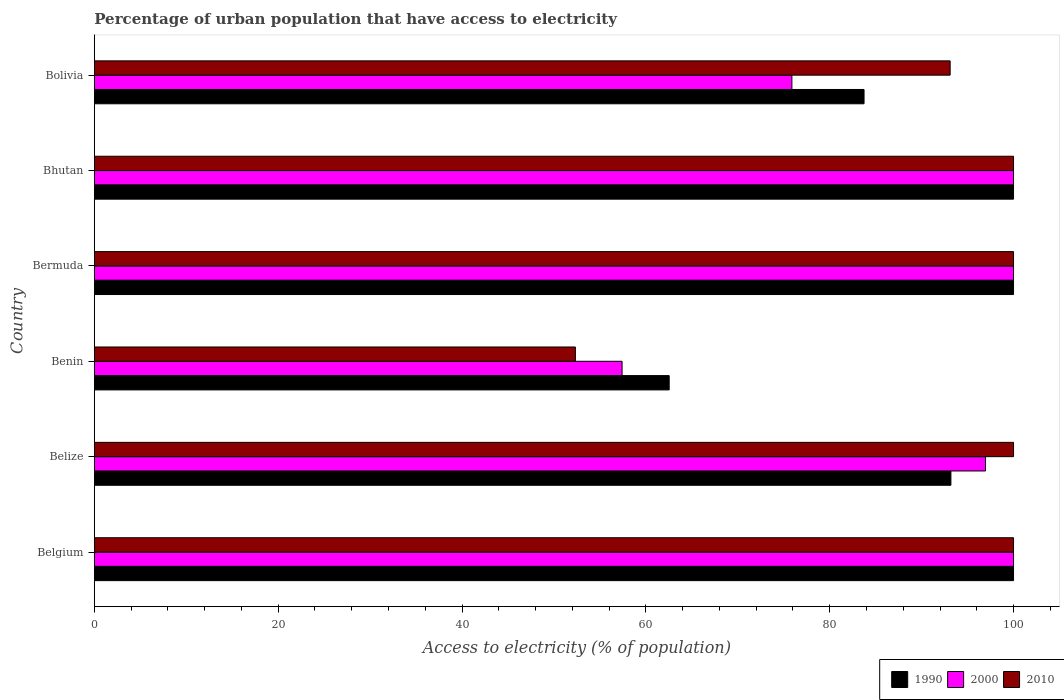How many different coloured bars are there?
Offer a very short reply. 3. How many groups of bars are there?
Your answer should be very brief. 6. Are the number of bars per tick equal to the number of legend labels?
Keep it short and to the point. Yes. Are the number of bars on each tick of the Y-axis equal?
Offer a terse response. Yes. How many bars are there on the 2nd tick from the top?
Provide a succinct answer. 3. What is the label of the 3rd group of bars from the top?
Make the answer very short. Bermuda. What is the percentage of urban population that have access to electricity in 1990 in Belgium?
Offer a terse response. 100. Across all countries, what is the minimum percentage of urban population that have access to electricity in 2000?
Offer a very short reply. 57.41. In which country was the percentage of urban population that have access to electricity in 1990 maximum?
Make the answer very short. Belgium. In which country was the percentage of urban population that have access to electricity in 2000 minimum?
Make the answer very short. Benin. What is the total percentage of urban population that have access to electricity in 2000 in the graph?
Make the answer very short. 530.25. What is the difference between the percentage of urban population that have access to electricity in 2010 in Bermuda and that in Bolivia?
Your response must be concise. 6.9. What is the difference between the percentage of urban population that have access to electricity in 2000 in Bolivia and the percentage of urban population that have access to electricity in 1990 in Belgium?
Your response must be concise. -24.11. What is the average percentage of urban population that have access to electricity in 1990 per country?
Provide a succinct answer. 89.91. What is the difference between the percentage of urban population that have access to electricity in 1990 and percentage of urban population that have access to electricity in 2010 in Benin?
Provide a short and direct response. 10.2. In how many countries, is the percentage of urban population that have access to electricity in 2000 greater than 68 %?
Your answer should be compact. 5. What is the ratio of the percentage of urban population that have access to electricity in 2010 in Benin to that in Bolivia?
Give a very brief answer. 0.56. Is the percentage of urban population that have access to electricity in 1990 in Benin less than that in Bolivia?
Ensure brevity in your answer.  Yes. What is the difference between the highest and the second highest percentage of urban population that have access to electricity in 1990?
Provide a succinct answer. 0. What is the difference between the highest and the lowest percentage of urban population that have access to electricity in 2000?
Offer a very short reply. 42.59. What does the 3rd bar from the top in Bolivia represents?
Ensure brevity in your answer.  1990. Is it the case that in every country, the sum of the percentage of urban population that have access to electricity in 2000 and percentage of urban population that have access to electricity in 1990 is greater than the percentage of urban population that have access to electricity in 2010?
Offer a very short reply. Yes. How many bars are there?
Make the answer very short. 18. How many countries are there in the graph?
Ensure brevity in your answer.  6. What is the difference between two consecutive major ticks on the X-axis?
Offer a terse response. 20. Where does the legend appear in the graph?
Ensure brevity in your answer.  Bottom right. How many legend labels are there?
Give a very brief answer. 3. How are the legend labels stacked?
Ensure brevity in your answer.  Horizontal. What is the title of the graph?
Your answer should be compact. Percentage of urban population that have access to electricity. Does "1982" appear as one of the legend labels in the graph?
Ensure brevity in your answer.  No. What is the label or title of the X-axis?
Give a very brief answer. Access to electricity (% of population). What is the label or title of the Y-axis?
Provide a succinct answer. Country. What is the Access to electricity (% of population) in 2000 in Belgium?
Ensure brevity in your answer.  100. What is the Access to electricity (% of population) in 2010 in Belgium?
Ensure brevity in your answer.  100. What is the Access to electricity (% of population) of 1990 in Belize?
Keep it short and to the point. 93.19. What is the Access to electricity (% of population) of 2000 in Belize?
Give a very brief answer. 96.95. What is the Access to electricity (% of population) in 1990 in Benin?
Offer a very short reply. 62.54. What is the Access to electricity (% of population) in 2000 in Benin?
Offer a terse response. 57.41. What is the Access to electricity (% of population) of 2010 in Benin?
Offer a very short reply. 52.33. What is the Access to electricity (% of population) of 2000 in Bermuda?
Your response must be concise. 100. What is the Access to electricity (% of population) of 2000 in Bhutan?
Provide a succinct answer. 100. What is the Access to electricity (% of population) in 2010 in Bhutan?
Your answer should be very brief. 100. What is the Access to electricity (% of population) in 1990 in Bolivia?
Ensure brevity in your answer.  83.74. What is the Access to electricity (% of population) in 2000 in Bolivia?
Give a very brief answer. 75.89. What is the Access to electricity (% of population) of 2010 in Bolivia?
Provide a short and direct response. 93.1. Across all countries, what is the maximum Access to electricity (% of population) in 1990?
Your answer should be compact. 100. Across all countries, what is the minimum Access to electricity (% of population) of 1990?
Make the answer very short. 62.54. Across all countries, what is the minimum Access to electricity (% of population) of 2000?
Offer a very short reply. 57.41. Across all countries, what is the minimum Access to electricity (% of population) in 2010?
Your response must be concise. 52.33. What is the total Access to electricity (% of population) of 1990 in the graph?
Provide a short and direct response. 539.46. What is the total Access to electricity (% of population) of 2000 in the graph?
Offer a very short reply. 530.25. What is the total Access to electricity (% of population) of 2010 in the graph?
Your answer should be very brief. 545.44. What is the difference between the Access to electricity (% of population) in 1990 in Belgium and that in Belize?
Make the answer very short. 6.81. What is the difference between the Access to electricity (% of population) in 2000 in Belgium and that in Belize?
Your response must be concise. 3.05. What is the difference between the Access to electricity (% of population) in 1990 in Belgium and that in Benin?
Provide a succinct answer. 37.46. What is the difference between the Access to electricity (% of population) in 2000 in Belgium and that in Benin?
Give a very brief answer. 42.59. What is the difference between the Access to electricity (% of population) of 2010 in Belgium and that in Benin?
Provide a succinct answer. 47.67. What is the difference between the Access to electricity (% of population) in 1990 in Belgium and that in Bermuda?
Ensure brevity in your answer.  0. What is the difference between the Access to electricity (% of population) in 2010 in Belgium and that in Bermuda?
Ensure brevity in your answer.  0. What is the difference between the Access to electricity (% of population) of 2000 in Belgium and that in Bhutan?
Offer a very short reply. 0. What is the difference between the Access to electricity (% of population) of 2010 in Belgium and that in Bhutan?
Give a very brief answer. 0. What is the difference between the Access to electricity (% of population) in 1990 in Belgium and that in Bolivia?
Keep it short and to the point. 16.26. What is the difference between the Access to electricity (% of population) in 2000 in Belgium and that in Bolivia?
Ensure brevity in your answer.  24.11. What is the difference between the Access to electricity (% of population) of 2010 in Belgium and that in Bolivia?
Give a very brief answer. 6.9. What is the difference between the Access to electricity (% of population) of 1990 in Belize and that in Benin?
Give a very brief answer. 30.65. What is the difference between the Access to electricity (% of population) of 2000 in Belize and that in Benin?
Provide a succinct answer. 39.53. What is the difference between the Access to electricity (% of population) in 2010 in Belize and that in Benin?
Your answer should be very brief. 47.67. What is the difference between the Access to electricity (% of population) of 1990 in Belize and that in Bermuda?
Your answer should be very brief. -6.81. What is the difference between the Access to electricity (% of population) in 2000 in Belize and that in Bermuda?
Your answer should be compact. -3.05. What is the difference between the Access to electricity (% of population) in 2010 in Belize and that in Bermuda?
Provide a succinct answer. 0. What is the difference between the Access to electricity (% of population) in 1990 in Belize and that in Bhutan?
Give a very brief answer. -6.81. What is the difference between the Access to electricity (% of population) in 2000 in Belize and that in Bhutan?
Your answer should be compact. -3.05. What is the difference between the Access to electricity (% of population) of 1990 in Belize and that in Bolivia?
Your response must be concise. 9.45. What is the difference between the Access to electricity (% of population) in 2000 in Belize and that in Bolivia?
Offer a very short reply. 21.06. What is the difference between the Access to electricity (% of population) in 2010 in Belize and that in Bolivia?
Your answer should be compact. 6.9. What is the difference between the Access to electricity (% of population) of 1990 in Benin and that in Bermuda?
Provide a succinct answer. -37.46. What is the difference between the Access to electricity (% of population) of 2000 in Benin and that in Bermuda?
Provide a succinct answer. -42.59. What is the difference between the Access to electricity (% of population) in 2010 in Benin and that in Bermuda?
Your answer should be very brief. -47.67. What is the difference between the Access to electricity (% of population) of 1990 in Benin and that in Bhutan?
Make the answer very short. -37.46. What is the difference between the Access to electricity (% of population) of 2000 in Benin and that in Bhutan?
Your answer should be very brief. -42.59. What is the difference between the Access to electricity (% of population) in 2010 in Benin and that in Bhutan?
Keep it short and to the point. -47.67. What is the difference between the Access to electricity (% of population) in 1990 in Benin and that in Bolivia?
Ensure brevity in your answer.  -21.2. What is the difference between the Access to electricity (% of population) in 2000 in Benin and that in Bolivia?
Offer a terse response. -18.47. What is the difference between the Access to electricity (% of population) in 2010 in Benin and that in Bolivia?
Offer a very short reply. -40.77. What is the difference between the Access to electricity (% of population) in 1990 in Bermuda and that in Bhutan?
Ensure brevity in your answer.  0. What is the difference between the Access to electricity (% of population) of 2010 in Bermuda and that in Bhutan?
Give a very brief answer. 0. What is the difference between the Access to electricity (% of population) of 1990 in Bermuda and that in Bolivia?
Your answer should be compact. 16.26. What is the difference between the Access to electricity (% of population) in 2000 in Bermuda and that in Bolivia?
Make the answer very short. 24.11. What is the difference between the Access to electricity (% of population) in 2010 in Bermuda and that in Bolivia?
Give a very brief answer. 6.9. What is the difference between the Access to electricity (% of population) in 1990 in Bhutan and that in Bolivia?
Ensure brevity in your answer.  16.26. What is the difference between the Access to electricity (% of population) in 2000 in Bhutan and that in Bolivia?
Offer a very short reply. 24.11. What is the difference between the Access to electricity (% of population) in 2010 in Bhutan and that in Bolivia?
Provide a short and direct response. 6.9. What is the difference between the Access to electricity (% of population) of 1990 in Belgium and the Access to electricity (% of population) of 2000 in Belize?
Ensure brevity in your answer.  3.05. What is the difference between the Access to electricity (% of population) in 1990 in Belgium and the Access to electricity (% of population) in 2010 in Belize?
Make the answer very short. 0. What is the difference between the Access to electricity (% of population) in 1990 in Belgium and the Access to electricity (% of population) in 2000 in Benin?
Keep it short and to the point. 42.59. What is the difference between the Access to electricity (% of population) of 1990 in Belgium and the Access to electricity (% of population) of 2010 in Benin?
Provide a short and direct response. 47.67. What is the difference between the Access to electricity (% of population) of 2000 in Belgium and the Access to electricity (% of population) of 2010 in Benin?
Your answer should be very brief. 47.67. What is the difference between the Access to electricity (% of population) of 2000 in Belgium and the Access to electricity (% of population) of 2010 in Bermuda?
Make the answer very short. 0. What is the difference between the Access to electricity (% of population) in 1990 in Belgium and the Access to electricity (% of population) in 2010 in Bhutan?
Provide a short and direct response. 0. What is the difference between the Access to electricity (% of population) of 1990 in Belgium and the Access to electricity (% of population) of 2000 in Bolivia?
Your answer should be very brief. 24.11. What is the difference between the Access to electricity (% of population) in 1990 in Belgium and the Access to electricity (% of population) in 2010 in Bolivia?
Provide a succinct answer. 6.9. What is the difference between the Access to electricity (% of population) in 2000 in Belgium and the Access to electricity (% of population) in 2010 in Bolivia?
Ensure brevity in your answer.  6.9. What is the difference between the Access to electricity (% of population) of 1990 in Belize and the Access to electricity (% of population) of 2000 in Benin?
Provide a short and direct response. 35.77. What is the difference between the Access to electricity (% of population) of 1990 in Belize and the Access to electricity (% of population) of 2010 in Benin?
Make the answer very short. 40.85. What is the difference between the Access to electricity (% of population) in 2000 in Belize and the Access to electricity (% of population) in 2010 in Benin?
Keep it short and to the point. 44.61. What is the difference between the Access to electricity (% of population) of 1990 in Belize and the Access to electricity (% of population) of 2000 in Bermuda?
Your answer should be very brief. -6.81. What is the difference between the Access to electricity (% of population) of 1990 in Belize and the Access to electricity (% of population) of 2010 in Bermuda?
Your answer should be compact. -6.81. What is the difference between the Access to electricity (% of population) of 2000 in Belize and the Access to electricity (% of population) of 2010 in Bermuda?
Give a very brief answer. -3.05. What is the difference between the Access to electricity (% of population) in 1990 in Belize and the Access to electricity (% of population) in 2000 in Bhutan?
Give a very brief answer. -6.81. What is the difference between the Access to electricity (% of population) in 1990 in Belize and the Access to electricity (% of population) in 2010 in Bhutan?
Offer a very short reply. -6.81. What is the difference between the Access to electricity (% of population) of 2000 in Belize and the Access to electricity (% of population) of 2010 in Bhutan?
Provide a succinct answer. -3.05. What is the difference between the Access to electricity (% of population) in 1990 in Belize and the Access to electricity (% of population) in 2000 in Bolivia?
Provide a short and direct response. 17.3. What is the difference between the Access to electricity (% of population) of 1990 in Belize and the Access to electricity (% of population) of 2010 in Bolivia?
Offer a terse response. 0.08. What is the difference between the Access to electricity (% of population) of 2000 in Belize and the Access to electricity (% of population) of 2010 in Bolivia?
Offer a very short reply. 3.84. What is the difference between the Access to electricity (% of population) in 1990 in Benin and the Access to electricity (% of population) in 2000 in Bermuda?
Keep it short and to the point. -37.46. What is the difference between the Access to electricity (% of population) in 1990 in Benin and the Access to electricity (% of population) in 2010 in Bermuda?
Provide a short and direct response. -37.46. What is the difference between the Access to electricity (% of population) of 2000 in Benin and the Access to electricity (% of population) of 2010 in Bermuda?
Offer a very short reply. -42.59. What is the difference between the Access to electricity (% of population) of 1990 in Benin and the Access to electricity (% of population) of 2000 in Bhutan?
Ensure brevity in your answer.  -37.46. What is the difference between the Access to electricity (% of population) in 1990 in Benin and the Access to electricity (% of population) in 2010 in Bhutan?
Keep it short and to the point. -37.46. What is the difference between the Access to electricity (% of population) of 2000 in Benin and the Access to electricity (% of population) of 2010 in Bhutan?
Offer a terse response. -42.59. What is the difference between the Access to electricity (% of population) in 1990 in Benin and the Access to electricity (% of population) in 2000 in Bolivia?
Ensure brevity in your answer.  -13.35. What is the difference between the Access to electricity (% of population) in 1990 in Benin and the Access to electricity (% of population) in 2010 in Bolivia?
Your answer should be very brief. -30.57. What is the difference between the Access to electricity (% of population) in 2000 in Benin and the Access to electricity (% of population) in 2010 in Bolivia?
Give a very brief answer. -35.69. What is the difference between the Access to electricity (% of population) of 1990 in Bermuda and the Access to electricity (% of population) of 2000 in Bolivia?
Your response must be concise. 24.11. What is the difference between the Access to electricity (% of population) in 1990 in Bermuda and the Access to electricity (% of population) in 2010 in Bolivia?
Give a very brief answer. 6.9. What is the difference between the Access to electricity (% of population) of 2000 in Bermuda and the Access to electricity (% of population) of 2010 in Bolivia?
Provide a short and direct response. 6.9. What is the difference between the Access to electricity (% of population) of 1990 in Bhutan and the Access to electricity (% of population) of 2000 in Bolivia?
Offer a terse response. 24.11. What is the difference between the Access to electricity (% of population) in 1990 in Bhutan and the Access to electricity (% of population) in 2010 in Bolivia?
Provide a short and direct response. 6.9. What is the difference between the Access to electricity (% of population) of 2000 in Bhutan and the Access to electricity (% of population) of 2010 in Bolivia?
Ensure brevity in your answer.  6.9. What is the average Access to electricity (% of population) of 1990 per country?
Offer a very short reply. 89.91. What is the average Access to electricity (% of population) of 2000 per country?
Offer a terse response. 88.37. What is the average Access to electricity (% of population) of 2010 per country?
Offer a terse response. 90.91. What is the difference between the Access to electricity (% of population) of 1990 and Access to electricity (% of population) of 2000 in Belgium?
Provide a succinct answer. 0. What is the difference between the Access to electricity (% of population) of 1990 and Access to electricity (% of population) of 2010 in Belgium?
Your answer should be compact. 0. What is the difference between the Access to electricity (% of population) in 2000 and Access to electricity (% of population) in 2010 in Belgium?
Give a very brief answer. 0. What is the difference between the Access to electricity (% of population) in 1990 and Access to electricity (% of population) in 2000 in Belize?
Ensure brevity in your answer.  -3.76. What is the difference between the Access to electricity (% of population) of 1990 and Access to electricity (% of population) of 2010 in Belize?
Your answer should be compact. -6.81. What is the difference between the Access to electricity (% of population) in 2000 and Access to electricity (% of population) in 2010 in Belize?
Make the answer very short. -3.05. What is the difference between the Access to electricity (% of population) of 1990 and Access to electricity (% of population) of 2000 in Benin?
Ensure brevity in your answer.  5.12. What is the difference between the Access to electricity (% of population) of 1990 and Access to electricity (% of population) of 2010 in Benin?
Provide a short and direct response. 10.2. What is the difference between the Access to electricity (% of population) in 2000 and Access to electricity (% of population) in 2010 in Benin?
Ensure brevity in your answer.  5.08. What is the difference between the Access to electricity (% of population) of 1990 and Access to electricity (% of population) of 2000 in Bermuda?
Ensure brevity in your answer.  0. What is the difference between the Access to electricity (% of population) in 1990 and Access to electricity (% of population) in 2010 in Bermuda?
Offer a very short reply. 0. What is the difference between the Access to electricity (% of population) in 1990 and Access to electricity (% of population) in 2000 in Bhutan?
Ensure brevity in your answer.  0. What is the difference between the Access to electricity (% of population) in 1990 and Access to electricity (% of population) in 2010 in Bhutan?
Offer a very short reply. 0. What is the difference between the Access to electricity (% of population) in 2000 and Access to electricity (% of population) in 2010 in Bhutan?
Your response must be concise. 0. What is the difference between the Access to electricity (% of population) of 1990 and Access to electricity (% of population) of 2000 in Bolivia?
Your response must be concise. 7.85. What is the difference between the Access to electricity (% of population) in 1990 and Access to electricity (% of population) in 2010 in Bolivia?
Ensure brevity in your answer.  -9.37. What is the difference between the Access to electricity (% of population) of 2000 and Access to electricity (% of population) of 2010 in Bolivia?
Offer a terse response. -17.22. What is the ratio of the Access to electricity (% of population) in 1990 in Belgium to that in Belize?
Your response must be concise. 1.07. What is the ratio of the Access to electricity (% of population) in 2000 in Belgium to that in Belize?
Offer a terse response. 1.03. What is the ratio of the Access to electricity (% of population) of 2010 in Belgium to that in Belize?
Ensure brevity in your answer.  1. What is the ratio of the Access to electricity (% of population) of 1990 in Belgium to that in Benin?
Provide a succinct answer. 1.6. What is the ratio of the Access to electricity (% of population) of 2000 in Belgium to that in Benin?
Offer a terse response. 1.74. What is the ratio of the Access to electricity (% of population) of 2010 in Belgium to that in Benin?
Provide a succinct answer. 1.91. What is the ratio of the Access to electricity (% of population) in 1990 in Belgium to that in Bermuda?
Your response must be concise. 1. What is the ratio of the Access to electricity (% of population) in 2000 in Belgium to that in Bhutan?
Provide a short and direct response. 1. What is the ratio of the Access to electricity (% of population) in 1990 in Belgium to that in Bolivia?
Offer a terse response. 1.19. What is the ratio of the Access to electricity (% of population) in 2000 in Belgium to that in Bolivia?
Offer a very short reply. 1.32. What is the ratio of the Access to electricity (% of population) of 2010 in Belgium to that in Bolivia?
Ensure brevity in your answer.  1.07. What is the ratio of the Access to electricity (% of population) in 1990 in Belize to that in Benin?
Make the answer very short. 1.49. What is the ratio of the Access to electricity (% of population) of 2000 in Belize to that in Benin?
Provide a short and direct response. 1.69. What is the ratio of the Access to electricity (% of population) in 2010 in Belize to that in Benin?
Your answer should be very brief. 1.91. What is the ratio of the Access to electricity (% of population) of 1990 in Belize to that in Bermuda?
Give a very brief answer. 0.93. What is the ratio of the Access to electricity (% of population) of 2000 in Belize to that in Bermuda?
Give a very brief answer. 0.97. What is the ratio of the Access to electricity (% of population) in 1990 in Belize to that in Bhutan?
Your answer should be compact. 0.93. What is the ratio of the Access to electricity (% of population) in 2000 in Belize to that in Bhutan?
Provide a short and direct response. 0.97. What is the ratio of the Access to electricity (% of population) of 2010 in Belize to that in Bhutan?
Make the answer very short. 1. What is the ratio of the Access to electricity (% of population) in 1990 in Belize to that in Bolivia?
Make the answer very short. 1.11. What is the ratio of the Access to electricity (% of population) in 2000 in Belize to that in Bolivia?
Make the answer very short. 1.28. What is the ratio of the Access to electricity (% of population) of 2010 in Belize to that in Bolivia?
Offer a terse response. 1.07. What is the ratio of the Access to electricity (% of population) in 1990 in Benin to that in Bermuda?
Ensure brevity in your answer.  0.63. What is the ratio of the Access to electricity (% of population) in 2000 in Benin to that in Bermuda?
Your answer should be very brief. 0.57. What is the ratio of the Access to electricity (% of population) of 2010 in Benin to that in Bermuda?
Provide a succinct answer. 0.52. What is the ratio of the Access to electricity (% of population) of 1990 in Benin to that in Bhutan?
Make the answer very short. 0.63. What is the ratio of the Access to electricity (% of population) in 2000 in Benin to that in Bhutan?
Give a very brief answer. 0.57. What is the ratio of the Access to electricity (% of population) of 2010 in Benin to that in Bhutan?
Give a very brief answer. 0.52. What is the ratio of the Access to electricity (% of population) of 1990 in Benin to that in Bolivia?
Offer a terse response. 0.75. What is the ratio of the Access to electricity (% of population) in 2000 in Benin to that in Bolivia?
Keep it short and to the point. 0.76. What is the ratio of the Access to electricity (% of population) of 2010 in Benin to that in Bolivia?
Your response must be concise. 0.56. What is the ratio of the Access to electricity (% of population) of 1990 in Bermuda to that in Bolivia?
Give a very brief answer. 1.19. What is the ratio of the Access to electricity (% of population) in 2000 in Bermuda to that in Bolivia?
Provide a short and direct response. 1.32. What is the ratio of the Access to electricity (% of population) in 2010 in Bermuda to that in Bolivia?
Offer a very short reply. 1.07. What is the ratio of the Access to electricity (% of population) of 1990 in Bhutan to that in Bolivia?
Your answer should be compact. 1.19. What is the ratio of the Access to electricity (% of population) of 2000 in Bhutan to that in Bolivia?
Your response must be concise. 1.32. What is the ratio of the Access to electricity (% of population) of 2010 in Bhutan to that in Bolivia?
Make the answer very short. 1.07. What is the difference between the highest and the second highest Access to electricity (% of population) in 1990?
Keep it short and to the point. 0. What is the difference between the highest and the second highest Access to electricity (% of population) in 2010?
Give a very brief answer. 0. What is the difference between the highest and the lowest Access to electricity (% of population) of 1990?
Your answer should be compact. 37.46. What is the difference between the highest and the lowest Access to electricity (% of population) of 2000?
Your answer should be very brief. 42.59. What is the difference between the highest and the lowest Access to electricity (% of population) in 2010?
Your answer should be compact. 47.67. 